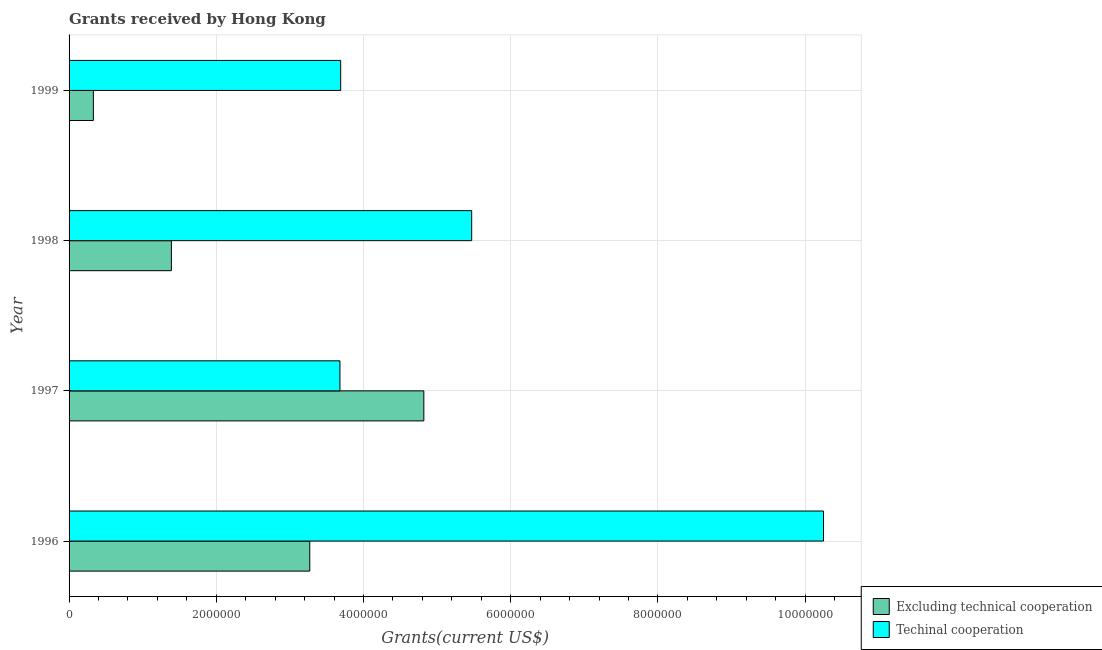How many different coloured bars are there?
Make the answer very short. 2. How many groups of bars are there?
Offer a terse response. 4. Are the number of bars on each tick of the Y-axis equal?
Offer a terse response. Yes. How many bars are there on the 1st tick from the bottom?
Provide a succinct answer. 2. In how many cases, is the number of bars for a given year not equal to the number of legend labels?
Give a very brief answer. 0. What is the amount of grants received(including technical cooperation) in 1999?
Your answer should be very brief. 3.69e+06. Across all years, what is the maximum amount of grants received(excluding technical cooperation)?
Your response must be concise. 4.82e+06. Across all years, what is the minimum amount of grants received(excluding technical cooperation)?
Provide a succinct answer. 3.30e+05. What is the total amount of grants received(excluding technical cooperation) in the graph?
Offer a terse response. 9.81e+06. What is the difference between the amount of grants received(excluding technical cooperation) in 1998 and that in 1999?
Offer a terse response. 1.06e+06. What is the difference between the amount of grants received(excluding technical cooperation) in 1997 and the amount of grants received(including technical cooperation) in 1996?
Ensure brevity in your answer.  -5.43e+06. What is the average amount of grants received(including technical cooperation) per year?
Ensure brevity in your answer.  5.77e+06. In the year 1997, what is the difference between the amount of grants received(including technical cooperation) and amount of grants received(excluding technical cooperation)?
Offer a terse response. -1.14e+06. What is the ratio of the amount of grants received(excluding technical cooperation) in 1997 to that in 1998?
Keep it short and to the point. 3.47. What is the difference between the highest and the second highest amount of grants received(excluding technical cooperation)?
Your response must be concise. 1.55e+06. What is the difference between the highest and the lowest amount of grants received(excluding technical cooperation)?
Offer a terse response. 4.49e+06. What does the 2nd bar from the top in 1996 represents?
Offer a terse response. Excluding technical cooperation. What does the 1st bar from the bottom in 1998 represents?
Keep it short and to the point. Excluding technical cooperation. How many bars are there?
Provide a succinct answer. 8. How many years are there in the graph?
Offer a terse response. 4. Are the values on the major ticks of X-axis written in scientific E-notation?
Your answer should be compact. No. Does the graph contain any zero values?
Ensure brevity in your answer.  No. Where does the legend appear in the graph?
Offer a terse response. Bottom right. How are the legend labels stacked?
Make the answer very short. Vertical. What is the title of the graph?
Your answer should be very brief. Grants received by Hong Kong. Does "Subsidies" appear as one of the legend labels in the graph?
Make the answer very short. No. What is the label or title of the X-axis?
Provide a succinct answer. Grants(current US$). What is the Grants(current US$) in Excluding technical cooperation in 1996?
Make the answer very short. 3.27e+06. What is the Grants(current US$) in Techinal cooperation in 1996?
Keep it short and to the point. 1.02e+07. What is the Grants(current US$) in Excluding technical cooperation in 1997?
Your answer should be compact. 4.82e+06. What is the Grants(current US$) of Techinal cooperation in 1997?
Your answer should be compact. 3.68e+06. What is the Grants(current US$) in Excluding technical cooperation in 1998?
Keep it short and to the point. 1.39e+06. What is the Grants(current US$) of Techinal cooperation in 1998?
Offer a very short reply. 5.47e+06. What is the Grants(current US$) in Excluding technical cooperation in 1999?
Your answer should be very brief. 3.30e+05. What is the Grants(current US$) of Techinal cooperation in 1999?
Your answer should be very brief. 3.69e+06. Across all years, what is the maximum Grants(current US$) of Excluding technical cooperation?
Your answer should be very brief. 4.82e+06. Across all years, what is the maximum Grants(current US$) in Techinal cooperation?
Provide a succinct answer. 1.02e+07. Across all years, what is the minimum Grants(current US$) in Excluding technical cooperation?
Offer a very short reply. 3.30e+05. Across all years, what is the minimum Grants(current US$) in Techinal cooperation?
Your answer should be compact. 3.68e+06. What is the total Grants(current US$) in Excluding technical cooperation in the graph?
Ensure brevity in your answer.  9.81e+06. What is the total Grants(current US$) in Techinal cooperation in the graph?
Offer a very short reply. 2.31e+07. What is the difference between the Grants(current US$) in Excluding technical cooperation in 1996 and that in 1997?
Your response must be concise. -1.55e+06. What is the difference between the Grants(current US$) of Techinal cooperation in 1996 and that in 1997?
Your response must be concise. 6.57e+06. What is the difference between the Grants(current US$) in Excluding technical cooperation in 1996 and that in 1998?
Offer a terse response. 1.88e+06. What is the difference between the Grants(current US$) in Techinal cooperation in 1996 and that in 1998?
Ensure brevity in your answer.  4.78e+06. What is the difference between the Grants(current US$) in Excluding technical cooperation in 1996 and that in 1999?
Keep it short and to the point. 2.94e+06. What is the difference between the Grants(current US$) in Techinal cooperation in 1996 and that in 1999?
Ensure brevity in your answer.  6.56e+06. What is the difference between the Grants(current US$) of Excluding technical cooperation in 1997 and that in 1998?
Give a very brief answer. 3.43e+06. What is the difference between the Grants(current US$) in Techinal cooperation in 1997 and that in 1998?
Your answer should be compact. -1.79e+06. What is the difference between the Grants(current US$) of Excluding technical cooperation in 1997 and that in 1999?
Offer a terse response. 4.49e+06. What is the difference between the Grants(current US$) in Techinal cooperation in 1997 and that in 1999?
Your answer should be compact. -10000. What is the difference between the Grants(current US$) of Excluding technical cooperation in 1998 and that in 1999?
Your answer should be very brief. 1.06e+06. What is the difference between the Grants(current US$) of Techinal cooperation in 1998 and that in 1999?
Give a very brief answer. 1.78e+06. What is the difference between the Grants(current US$) in Excluding technical cooperation in 1996 and the Grants(current US$) in Techinal cooperation in 1997?
Your answer should be compact. -4.10e+05. What is the difference between the Grants(current US$) of Excluding technical cooperation in 1996 and the Grants(current US$) of Techinal cooperation in 1998?
Your answer should be compact. -2.20e+06. What is the difference between the Grants(current US$) of Excluding technical cooperation in 1996 and the Grants(current US$) of Techinal cooperation in 1999?
Give a very brief answer. -4.20e+05. What is the difference between the Grants(current US$) of Excluding technical cooperation in 1997 and the Grants(current US$) of Techinal cooperation in 1998?
Offer a terse response. -6.50e+05. What is the difference between the Grants(current US$) of Excluding technical cooperation in 1997 and the Grants(current US$) of Techinal cooperation in 1999?
Provide a succinct answer. 1.13e+06. What is the difference between the Grants(current US$) of Excluding technical cooperation in 1998 and the Grants(current US$) of Techinal cooperation in 1999?
Your answer should be very brief. -2.30e+06. What is the average Grants(current US$) of Excluding technical cooperation per year?
Your response must be concise. 2.45e+06. What is the average Grants(current US$) in Techinal cooperation per year?
Offer a very short reply. 5.77e+06. In the year 1996, what is the difference between the Grants(current US$) of Excluding technical cooperation and Grants(current US$) of Techinal cooperation?
Your answer should be very brief. -6.98e+06. In the year 1997, what is the difference between the Grants(current US$) of Excluding technical cooperation and Grants(current US$) of Techinal cooperation?
Provide a succinct answer. 1.14e+06. In the year 1998, what is the difference between the Grants(current US$) in Excluding technical cooperation and Grants(current US$) in Techinal cooperation?
Your answer should be compact. -4.08e+06. In the year 1999, what is the difference between the Grants(current US$) in Excluding technical cooperation and Grants(current US$) in Techinal cooperation?
Keep it short and to the point. -3.36e+06. What is the ratio of the Grants(current US$) of Excluding technical cooperation in 1996 to that in 1997?
Your answer should be very brief. 0.68. What is the ratio of the Grants(current US$) in Techinal cooperation in 1996 to that in 1997?
Your answer should be compact. 2.79. What is the ratio of the Grants(current US$) in Excluding technical cooperation in 1996 to that in 1998?
Your response must be concise. 2.35. What is the ratio of the Grants(current US$) in Techinal cooperation in 1996 to that in 1998?
Your answer should be compact. 1.87. What is the ratio of the Grants(current US$) in Excluding technical cooperation in 1996 to that in 1999?
Ensure brevity in your answer.  9.91. What is the ratio of the Grants(current US$) in Techinal cooperation in 1996 to that in 1999?
Ensure brevity in your answer.  2.78. What is the ratio of the Grants(current US$) of Excluding technical cooperation in 1997 to that in 1998?
Make the answer very short. 3.47. What is the ratio of the Grants(current US$) of Techinal cooperation in 1997 to that in 1998?
Your answer should be compact. 0.67. What is the ratio of the Grants(current US$) of Excluding technical cooperation in 1997 to that in 1999?
Provide a short and direct response. 14.61. What is the ratio of the Grants(current US$) of Excluding technical cooperation in 1998 to that in 1999?
Offer a terse response. 4.21. What is the ratio of the Grants(current US$) in Techinal cooperation in 1998 to that in 1999?
Make the answer very short. 1.48. What is the difference between the highest and the second highest Grants(current US$) in Excluding technical cooperation?
Provide a succinct answer. 1.55e+06. What is the difference between the highest and the second highest Grants(current US$) in Techinal cooperation?
Give a very brief answer. 4.78e+06. What is the difference between the highest and the lowest Grants(current US$) of Excluding technical cooperation?
Ensure brevity in your answer.  4.49e+06. What is the difference between the highest and the lowest Grants(current US$) in Techinal cooperation?
Your answer should be compact. 6.57e+06. 